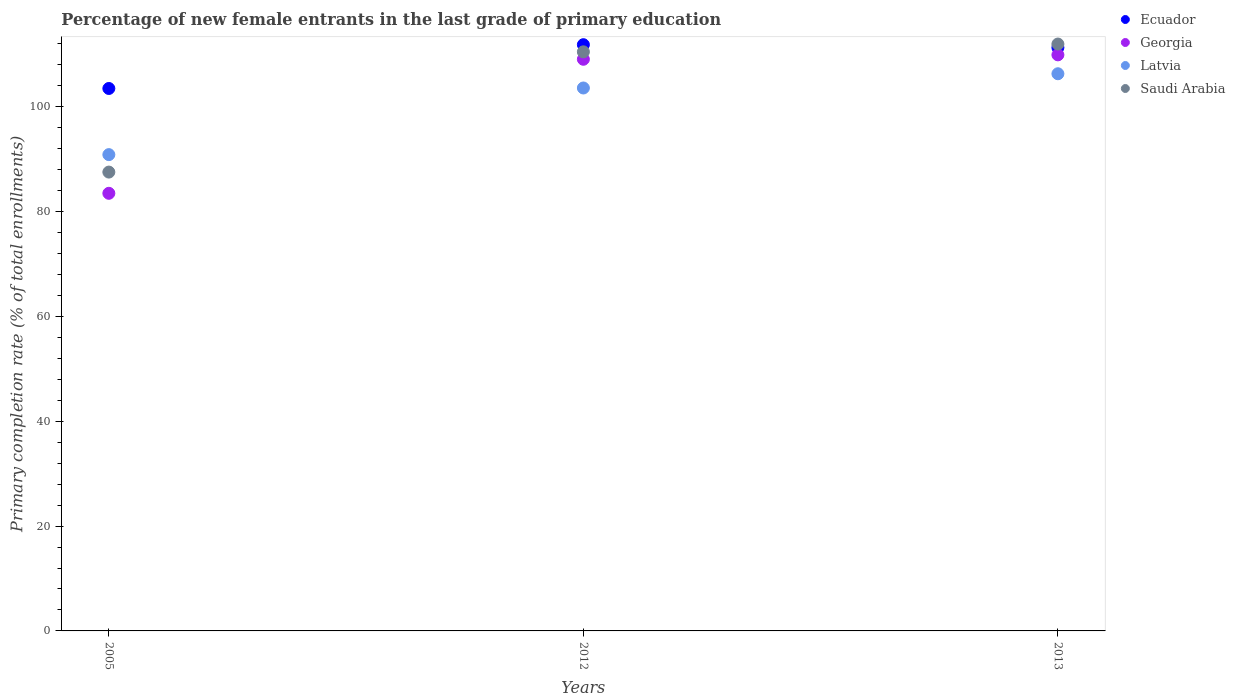How many different coloured dotlines are there?
Offer a terse response. 4. What is the percentage of new female entrants in Ecuador in 2013?
Offer a terse response. 111.3. Across all years, what is the maximum percentage of new female entrants in Latvia?
Your response must be concise. 106.31. Across all years, what is the minimum percentage of new female entrants in Ecuador?
Your answer should be compact. 103.5. In which year was the percentage of new female entrants in Ecuador maximum?
Provide a succinct answer. 2012. In which year was the percentage of new female entrants in Georgia minimum?
Your answer should be compact. 2005. What is the total percentage of new female entrants in Ecuador in the graph?
Ensure brevity in your answer.  326.65. What is the difference between the percentage of new female entrants in Ecuador in 2005 and that in 2012?
Your answer should be very brief. -8.36. What is the difference between the percentage of new female entrants in Latvia in 2013 and the percentage of new female entrants in Saudi Arabia in 2012?
Offer a very short reply. -4.18. What is the average percentage of new female entrants in Saudi Arabia per year?
Provide a short and direct response. 103.34. In the year 2012, what is the difference between the percentage of new female entrants in Latvia and percentage of new female entrants in Saudi Arabia?
Your response must be concise. -6.9. In how many years, is the percentage of new female entrants in Saudi Arabia greater than 88 %?
Ensure brevity in your answer.  2. What is the ratio of the percentage of new female entrants in Ecuador in 2005 to that in 2012?
Provide a succinct answer. 0.93. Is the percentage of new female entrants in Latvia in 2005 less than that in 2013?
Your answer should be compact. Yes. Is the difference between the percentage of new female entrants in Latvia in 2005 and 2013 greater than the difference between the percentage of new female entrants in Saudi Arabia in 2005 and 2013?
Keep it short and to the point. Yes. What is the difference between the highest and the second highest percentage of new female entrants in Saudi Arabia?
Ensure brevity in your answer.  1.49. What is the difference between the highest and the lowest percentage of new female entrants in Latvia?
Offer a terse response. 15.43. Is the sum of the percentage of new female entrants in Georgia in 2005 and 2012 greater than the maximum percentage of new female entrants in Latvia across all years?
Keep it short and to the point. Yes. Is it the case that in every year, the sum of the percentage of new female entrants in Ecuador and percentage of new female entrants in Saudi Arabia  is greater than the sum of percentage of new female entrants in Latvia and percentage of new female entrants in Georgia?
Your answer should be very brief. No. Is it the case that in every year, the sum of the percentage of new female entrants in Saudi Arabia and percentage of new female entrants in Georgia  is greater than the percentage of new female entrants in Latvia?
Your answer should be compact. Yes. Does the percentage of new female entrants in Latvia monotonically increase over the years?
Offer a very short reply. Yes. How many dotlines are there?
Ensure brevity in your answer.  4. Does the graph contain any zero values?
Offer a terse response. No. How many legend labels are there?
Your answer should be very brief. 4. How are the legend labels stacked?
Give a very brief answer. Vertical. What is the title of the graph?
Provide a short and direct response. Percentage of new female entrants in the last grade of primary education. Does "United Kingdom" appear as one of the legend labels in the graph?
Make the answer very short. No. What is the label or title of the X-axis?
Make the answer very short. Years. What is the label or title of the Y-axis?
Offer a terse response. Primary completion rate (% of total enrollments). What is the Primary completion rate (% of total enrollments) in Ecuador in 2005?
Provide a succinct answer. 103.5. What is the Primary completion rate (% of total enrollments) of Georgia in 2005?
Your answer should be compact. 83.49. What is the Primary completion rate (% of total enrollments) of Latvia in 2005?
Your answer should be very brief. 90.88. What is the Primary completion rate (% of total enrollments) of Saudi Arabia in 2005?
Keep it short and to the point. 87.54. What is the Primary completion rate (% of total enrollments) in Ecuador in 2012?
Your answer should be compact. 111.85. What is the Primary completion rate (% of total enrollments) of Georgia in 2012?
Your answer should be very brief. 109.07. What is the Primary completion rate (% of total enrollments) in Latvia in 2012?
Provide a succinct answer. 103.59. What is the Primary completion rate (% of total enrollments) of Saudi Arabia in 2012?
Make the answer very short. 110.49. What is the Primary completion rate (% of total enrollments) of Ecuador in 2013?
Ensure brevity in your answer.  111.3. What is the Primary completion rate (% of total enrollments) of Georgia in 2013?
Offer a very short reply. 109.91. What is the Primary completion rate (% of total enrollments) of Latvia in 2013?
Make the answer very short. 106.31. What is the Primary completion rate (% of total enrollments) in Saudi Arabia in 2013?
Provide a short and direct response. 111.98. Across all years, what is the maximum Primary completion rate (% of total enrollments) in Ecuador?
Your answer should be compact. 111.85. Across all years, what is the maximum Primary completion rate (% of total enrollments) of Georgia?
Keep it short and to the point. 109.91. Across all years, what is the maximum Primary completion rate (% of total enrollments) in Latvia?
Your response must be concise. 106.31. Across all years, what is the maximum Primary completion rate (% of total enrollments) of Saudi Arabia?
Offer a terse response. 111.98. Across all years, what is the minimum Primary completion rate (% of total enrollments) of Ecuador?
Make the answer very short. 103.5. Across all years, what is the minimum Primary completion rate (% of total enrollments) in Georgia?
Keep it short and to the point. 83.49. Across all years, what is the minimum Primary completion rate (% of total enrollments) in Latvia?
Keep it short and to the point. 90.88. Across all years, what is the minimum Primary completion rate (% of total enrollments) in Saudi Arabia?
Provide a short and direct response. 87.54. What is the total Primary completion rate (% of total enrollments) in Ecuador in the graph?
Ensure brevity in your answer.  326.65. What is the total Primary completion rate (% of total enrollments) of Georgia in the graph?
Ensure brevity in your answer.  302.48. What is the total Primary completion rate (% of total enrollments) of Latvia in the graph?
Your answer should be very brief. 300.77. What is the total Primary completion rate (% of total enrollments) in Saudi Arabia in the graph?
Offer a terse response. 310.01. What is the difference between the Primary completion rate (% of total enrollments) of Ecuador in 2005 and that in 2012?
Keep it short and to the point. -8.36. What is the difference between the Primary completion rate (% of total enrollments) in Georgia in 2005 and that in 2012?
Your answer should be compact. -25.57. What is the difference between the Primary completion rate (% of total enrollments) in Latvia in 2005 and that in 2012?
Your answer should be very brief. -12.71. What is the difference between the Primary completion rate (% of total enrollments) in Saudi Arabia in 2005 and that in 2012?
Make the answer very short. -22.94. What is the difference between the Primary completion rate (% of total enrollments) of Ecuador in 2005 and that in 2013?
Your answer should be very brief. -7.81. What is the difference between the Primary completion rate (% of total enrollments) of Georgia in 2005 and that in 2013?
Give a very brief answer. -26.42. What is the difference between the Primary completion rate (% of total enrollments) of Latvia in 2005 and that in 2013?
Give a very brief answer. -15.43. What is the difference between the Primary completion rate (% of total enrollments) of Saudi Arabia in 2005 and that in 2013?
Provide a succinct answer. -24.43. What is the difference between the Primary completion rate (% of total enrollments) of Ecuador in 2012 and that in 2013?
Your answer should be very brief. 0.55. What is the difference between the Primary completion rate (% of total enrollments) in Georgia in 2012 and that in 2013?
Your answer should be compact. -0.84. What is the difference between the Primary completion rate (% of total enrollments) of Latvia in 2012 and that in 2013?
Keep it short and to the point. -2.72. What is the difference between the Primary completion rate (% of total enrollments) of Saudi Arabia in 2012 and that in 2013?
Offer a terse response. -1.49. What is the difference between the Primary completion rate (% of total enrollments) in Ecuador in 2005 and the Primary completion rate (% of total enrollments) in Georgia in 2012?
Give a very brief answer. -5.57. What is the difference between the Primary completion rate (% of total enrollments) of Ecuador in 2005 and the Primary completion rate (% of total enrollments) of Latvia in 2012?
Keep it short and to the point. -0.09. What is the difference between the Primary completion rate (% of total enrollments) in Ecuador in 2005 and the Primary completion rate (% of total enrollments) in Saudi Arabia in 2012?
Your response must be concise. -6.99. What is the difference between the Primary completion rate (% of total enrollments) in Georgia in 2005 and the Primary completion rate (% of total enrollments) in Latvia in 2012?
Make the answer very short. -20.09. What is the difference between the Primary completion rate (% of total enrollments) of Georgia in 2005 and the Primary completion rate (% of total enrollments) of Saudi Arabia in 2012?
Provide a succinct answer. -26.99. What is the difference between the Primary completion rate (% of total enrollments) of Latvia in 2005 and the Primary completion rate (% of total enrollments) of Saudi Arabia in 2012?
Give a very brief answer. -19.61. What is the difference between the Primary completion rate (% of total enrollments) in Ecuador in 2005 and the Primary completion rate (% of total enrollments) in Georgia in 2013?
Your response must be concise. -6.42. What is the difference between the Primary completion rate (% of total enrollments) of Ecuador in 2005 and the Primary completion rate (% of total enrollments) of Latvia in 2013?
Keep it short and to the point. -2.81. What is the difference between the Primary completion rate (% of total enrollments) of Ecuador in 2005 and the Primary completion rate (% of total enrollments) of Saudi Arabia in 2013?
Your answer should be compact. -8.48. What is the difference between the Primary completion rate (% of total enrollments) in Georgia in 2005 and the Primary completion rate (% of total enrollments) in Latvia in 2013?
Your answer should be very brief. -22.81. What is the difference between the Primary completion rate (% of total enrollments) of Georgia in 2005 and the Primary completion rate (% of total enrollments) of Saudi Arabia in 2013?
Offer a very short reply. -28.48. What is the difference between the Primary completion rate (% of total enrollments) in Latvia in 2005 and the Primary completion rate (% of total enrollments) in Saudi Arabia in 2013?
Your answer should be compact. -21.1. What is the difference between the Primary completion rate (% of total enrollments) of Ecuador in 2012 and the Primary completion rate (% of total enrollments) of Georgia in 2013?
Your answer should be compact. 1.94. What is the difference between the Primary completion rate (% of total enrollments) of Ecuador in 2012 and the Primary completion rate (% of total enrollments) of Latvia in 2013?
Offer a terse response. 5.54. What is the difference between the Primary completion rate (% of total enrollments) of Ecuador in 2012 and the Primary completion rate (% of total enrollments) of Saudi Arabia in 2013?
Offer a very short reply. -0.12. What is the difference between the Primary completion rate (% of total enrollments) in Georgia in 2012 and the Primary completion rate (% of total enrollments) in Latvia in 2013?
Ensure brevity in your answer.  2.76. What is the difference between the Primary completion rate (% of total enrollments) in Georgia in 2012 and the Primary completion rate (% of total enrollments) in Saudi Arabia in 2013?
Keep it short and to the point. -2.91. What is the difference between the Primary completion rate (% of total enrollments) in Latvia in 2012 and the Primary completion rate (% of total enrollments) in Saudi Arabia in 2013?
Give a very brief answer. -8.39. What is the average Primary completion rate (% of total enrollments) in Ecuador per year?
Provide a short and direct response. 108.88. What is the average Primary completion rate (% of total enrollments) in Georgia per year?
Offer a terse response. 100.83. What is the average Primary completion rate (% of total enrollments) in Latvia per year?
Keep it short and to the point. 100.26. What is the average Primary completion rate (% of total enrollments) of Saudi Arabia per year?
Your answer should be very brief. 103.34. In the year 2005, what is the difference between the Primary completion rate (% of total enrollments) in Ecuador and Primary completion rate (% of total enrollments) in Georgia?
Provide a succinct answer. 20. In the year 2005, what is the difference between the Primary completion rate (% of total enrollments) of Ecuador and Primary completion rate (% of total enrollments) of Latvia?
Ensure brevity in your answer.  12.62. In the year 2005, what is the difference between the Primary completion rate (% of total enrollments) of Ecuador and Primary completion rate (% of total enrollments) of Saudi Arabia?
Give a very brief answer. 15.95. In the year 2005, what is the difference between the Primary completion rate (% of total enrollments) of Georgia and Primary completion rate (% of total enrollments) of Latvia?
Make the answer very short. -7.38. In the year 2005, what is the difference between the Primary completion rate (% of total enrollments) of Georgia and Primary completion rate (% of total enrollments) of Saudi Arabia?
Provide a short and direct response. -4.05. In the year 2005, what is the difference between the Primary completion rate (% of total enrollments) in Latvia and Primary completion rate (% of total enrollments) in Saudi Arabia?
Make the answer very short. 3.33. In the year 2012, what is the difference between the Primary completion rate (% of total enrollments) in Ecuador and Primary completion rate (% of total enrollments) in Georgia?
Your answer should be very brief. 2.78. In the year 2012, what is the difference between the Primary completion rate (% of total enrollments) in Ecuador and Primary completion rate (% of total enrollments) in Latvia?
Give a very brief answer. 8.26. In the year 2012, what is the difference between the Primary completion rate (% of total enrollments) of Ecuador and Primary completion rate (% of total enrollments) of Saudi Arabia?
Provide a short and direct response. 1.36. In the year 2012, what is the difference between the Primary completion rate (% of total enrollments) of Georgia and Primary completion rate (% of total enrollments) of Latvia?
Ensure brevity in your answer.  5.48. In the year 2012, what is the difference between the Primary completion rate (% of total enrollments) in Georgia and Primary completion rate (% of total enrollments) in Saudi Arabia?
Provide a succinct answer. -1.42. In the year 2012, what is the difference between the Primary completion rate (% of total enrollments) of Latvia and Primary completion rate (% of total enrollments) of Saudi Arabia?
Your response must be concise. -6.9. In the year 2013, what is the difference between the Primary completion rate (% of total enrollments) in Ecuador and Primary completion rate (% of total enrollments) in Georgia?
Your answer should be very brief. 1.39. In the year 2013, what is the difference between the Primary completion rate (% of total enrollments) in Ecuador and Primary completion rate (% of total enrollments) in Latvia?
Provide a short and direct response. 4.99. In the year 2013, what is the difference between the Primary completion rate (% of total enrollments) in Ecuador and Primary completion rate (% of total enrollments) in Saudi Arabia?
Your response must be concise. -0.67. In the year 2013, what is the difference between the Primary completion rate (% of total enrollments) in Georgia and Primary completion rate (% of total enrollments) in Latvia?
Provide a succinct answer. 3.6. In the year 2013, what is the difference between the Primary completion rate (% of total enrollments) of Georgia and Primary completion rate (% of total enrollments) of Saudi Arabia?
Offer a terse response. -2.06. In the year 2013, what is the difference between the Primary completion rate (% of total enrollments) in Latvia and Primary completion rate (% of total enrollments) in Saudi Arabia?
Offer a terse response. -5.67. What is the ratio of the Primary completion rate (% of total enrollments) in Ecuador in 2005 to that in 2012?
Provide a short and direct response. 0.93. What is the ratio of the Primary completion rate (% of total enrollments) in Georgia in 2005 to that in 2012?
Give a very brief answer. 0.77. What is the ratio of the Primary completion rate (% of total enrollments) in Latvia in 2005 to that in 2012?
Make the answer very short. 0.88. What is the ratio of the Primary completion rate (% of total enrollments) of Saudi Arabia in 2005 to that in 2012?
Make the answer very short. 0.79. What is the ratio of the Primary completion rate (% of total enrollments) in Ecuador in 2005 to that in 2013?
Make the answer very short. 0.93. What is the ratio of the Primary completion rate (% of total enrollments) in Georgia in 2005 to that in 2013?
Provide a succinct answer. 0.76. What is the ratio of the Primary completion rate (% of total enrollments) in Latvia in 2005 to that in 2013?
Your answer should be very brief. 0.85. What is the ratio of the Primary completion rate (% of total enrollments) of Saudi Arabia in 2005 to that in 2013?
Ensure brevity in your answer.  0.78. What is the ratio of the Primary completion rate (% of total enrollments) in Georgia in 2012 to that in 2013?
Your answer should be very brief. 0.99. What is the ratio of the Primary completion rate (% of total enrollments) of Latvia in 2012 to that in 2013?
Your answer should be compact. 0.97. What is the ratio of the Primary completion rate (% of total enrollments) of Saudi Arabia in 2012 to that in 2013?
Your answer should be very brief. 0.99. What is the difference between the highest and the second highest Primary completion rate (% of total enrollments) of Ecuador?
Your response must be concise. 0.55. What is the difference between the highest and the second highest Primary completion rate (% of total enrollments) in Georgia?
Ensure brevity in your answer.  0.84. What is the difference between the highest and the second highest Primary completion rate (% of total enrollments) of Latvia?
Your answer should be very brief. 2.72. What is the difference between the highest and the second highest Primary completion rate (% of total enrollments) of Saudi Arabia?
Keep it short and to the point. 1.49. What is the difference between the highest and the lowest Primary completion rate (% of total enrollments) in Ecuador?
Offer a very short reply. 8.36. What is the difference between the highest and the lowest Primary completion rate (% of total enrollments) in Georgia?
Give a very brief answer. 26.42. What is the difference between the highest and the lowest Primary completion rate (% of total enrollments) in Latvia?
Your response must be concise. 15.43. What is the difference between the highest and the lowest Primary completion rate (% of total enrollments) of Saudi Arabia?
Keep it short and to the point. 24.43. 